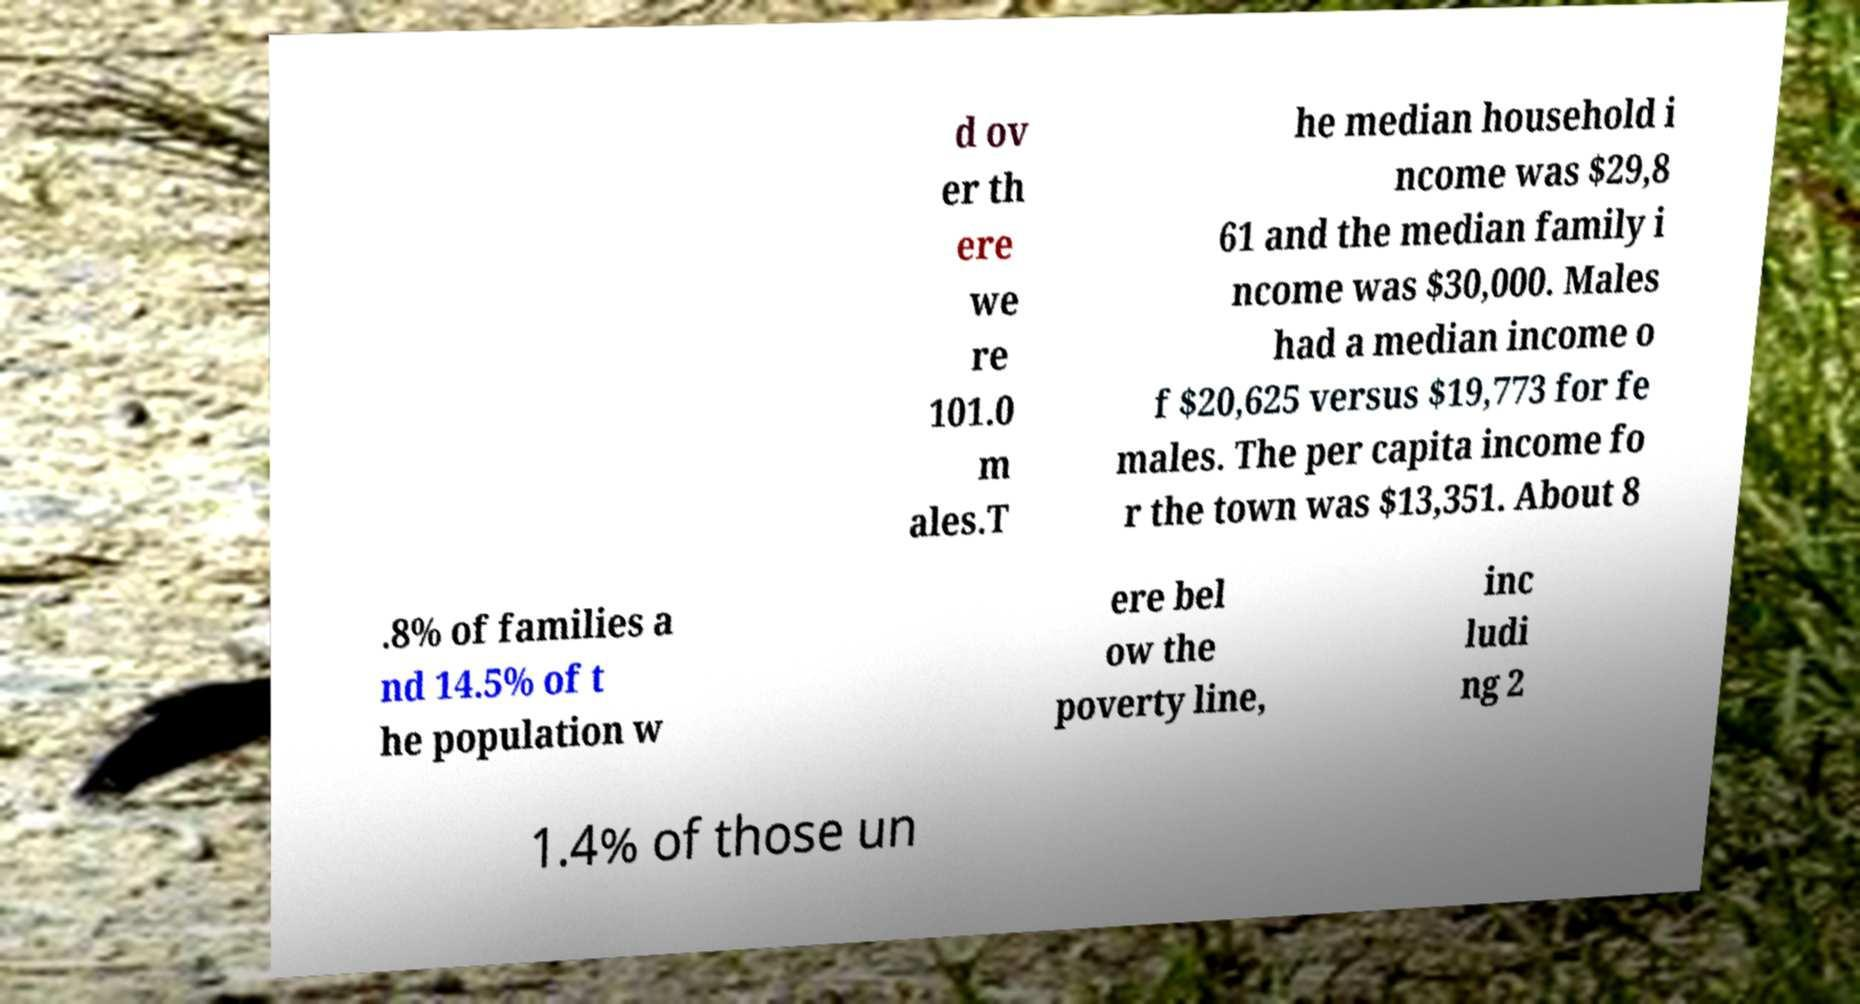Please read and relay the text visible in this image. What does it say? d ov er th ere we re 101.0 m ales.T he median household i ncome was $29,8 61 and the median family i ncome was $30,000. Males had a median income o f $20,625 versus $19,773 for fe males. The per capita income fo r the town was $13,351. About 8 .8% of families a nd 14.5% of t he population w ere bel ow the poverty line, inc ludi ng 2 1.4% of those un 